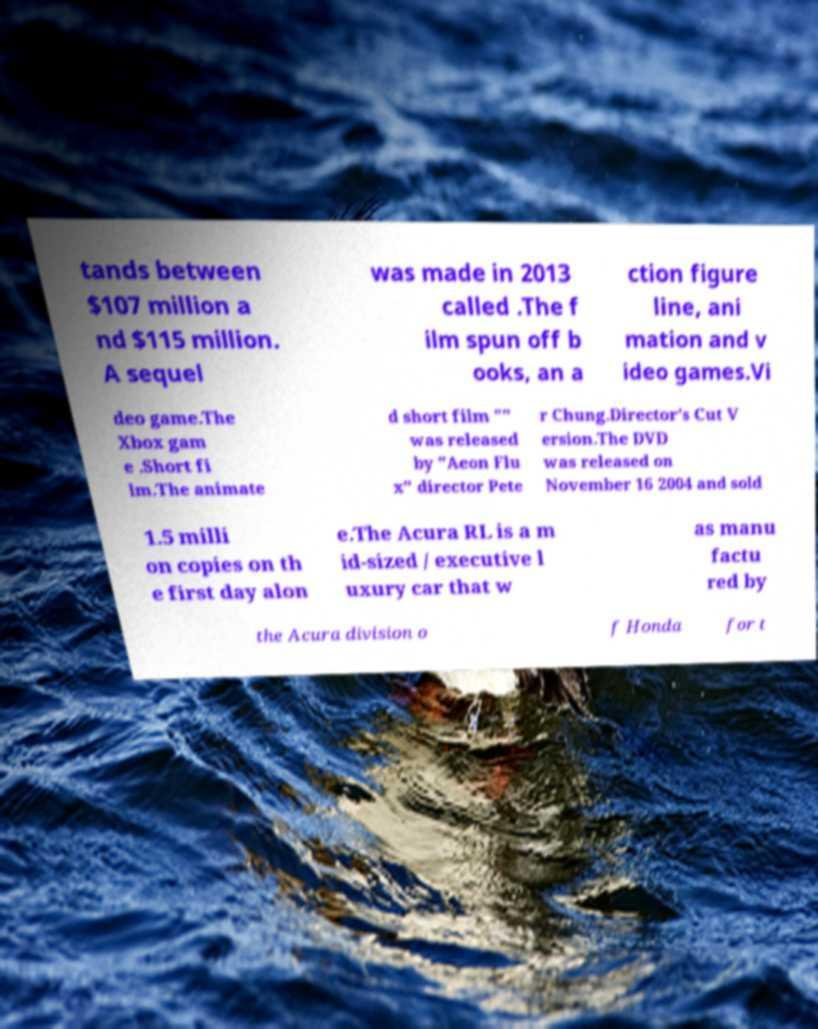Can you read and provide the text displayed in the image?This photo seems to have some interesting text. Can you extract and type it out for me? tands between $107 million a nd $115 million. A sequel was made in 2013 called .The f ilm spun off b ooks, an a ction figure line, ani mation and v ideo games.Vi deo game.The Xbox gam e .Short fi lm.The animate d short film "" was released by "Aeon Flu x" director Pete r Chung.Director's Cut V ersion.The DVD was released on November 16 2004 and sold 1.5 milli on copies on th e first day alon e.The Acura RL is a m id-sized / executive l uxury car that w as manu factu red by the Acura division o f Honda for t 